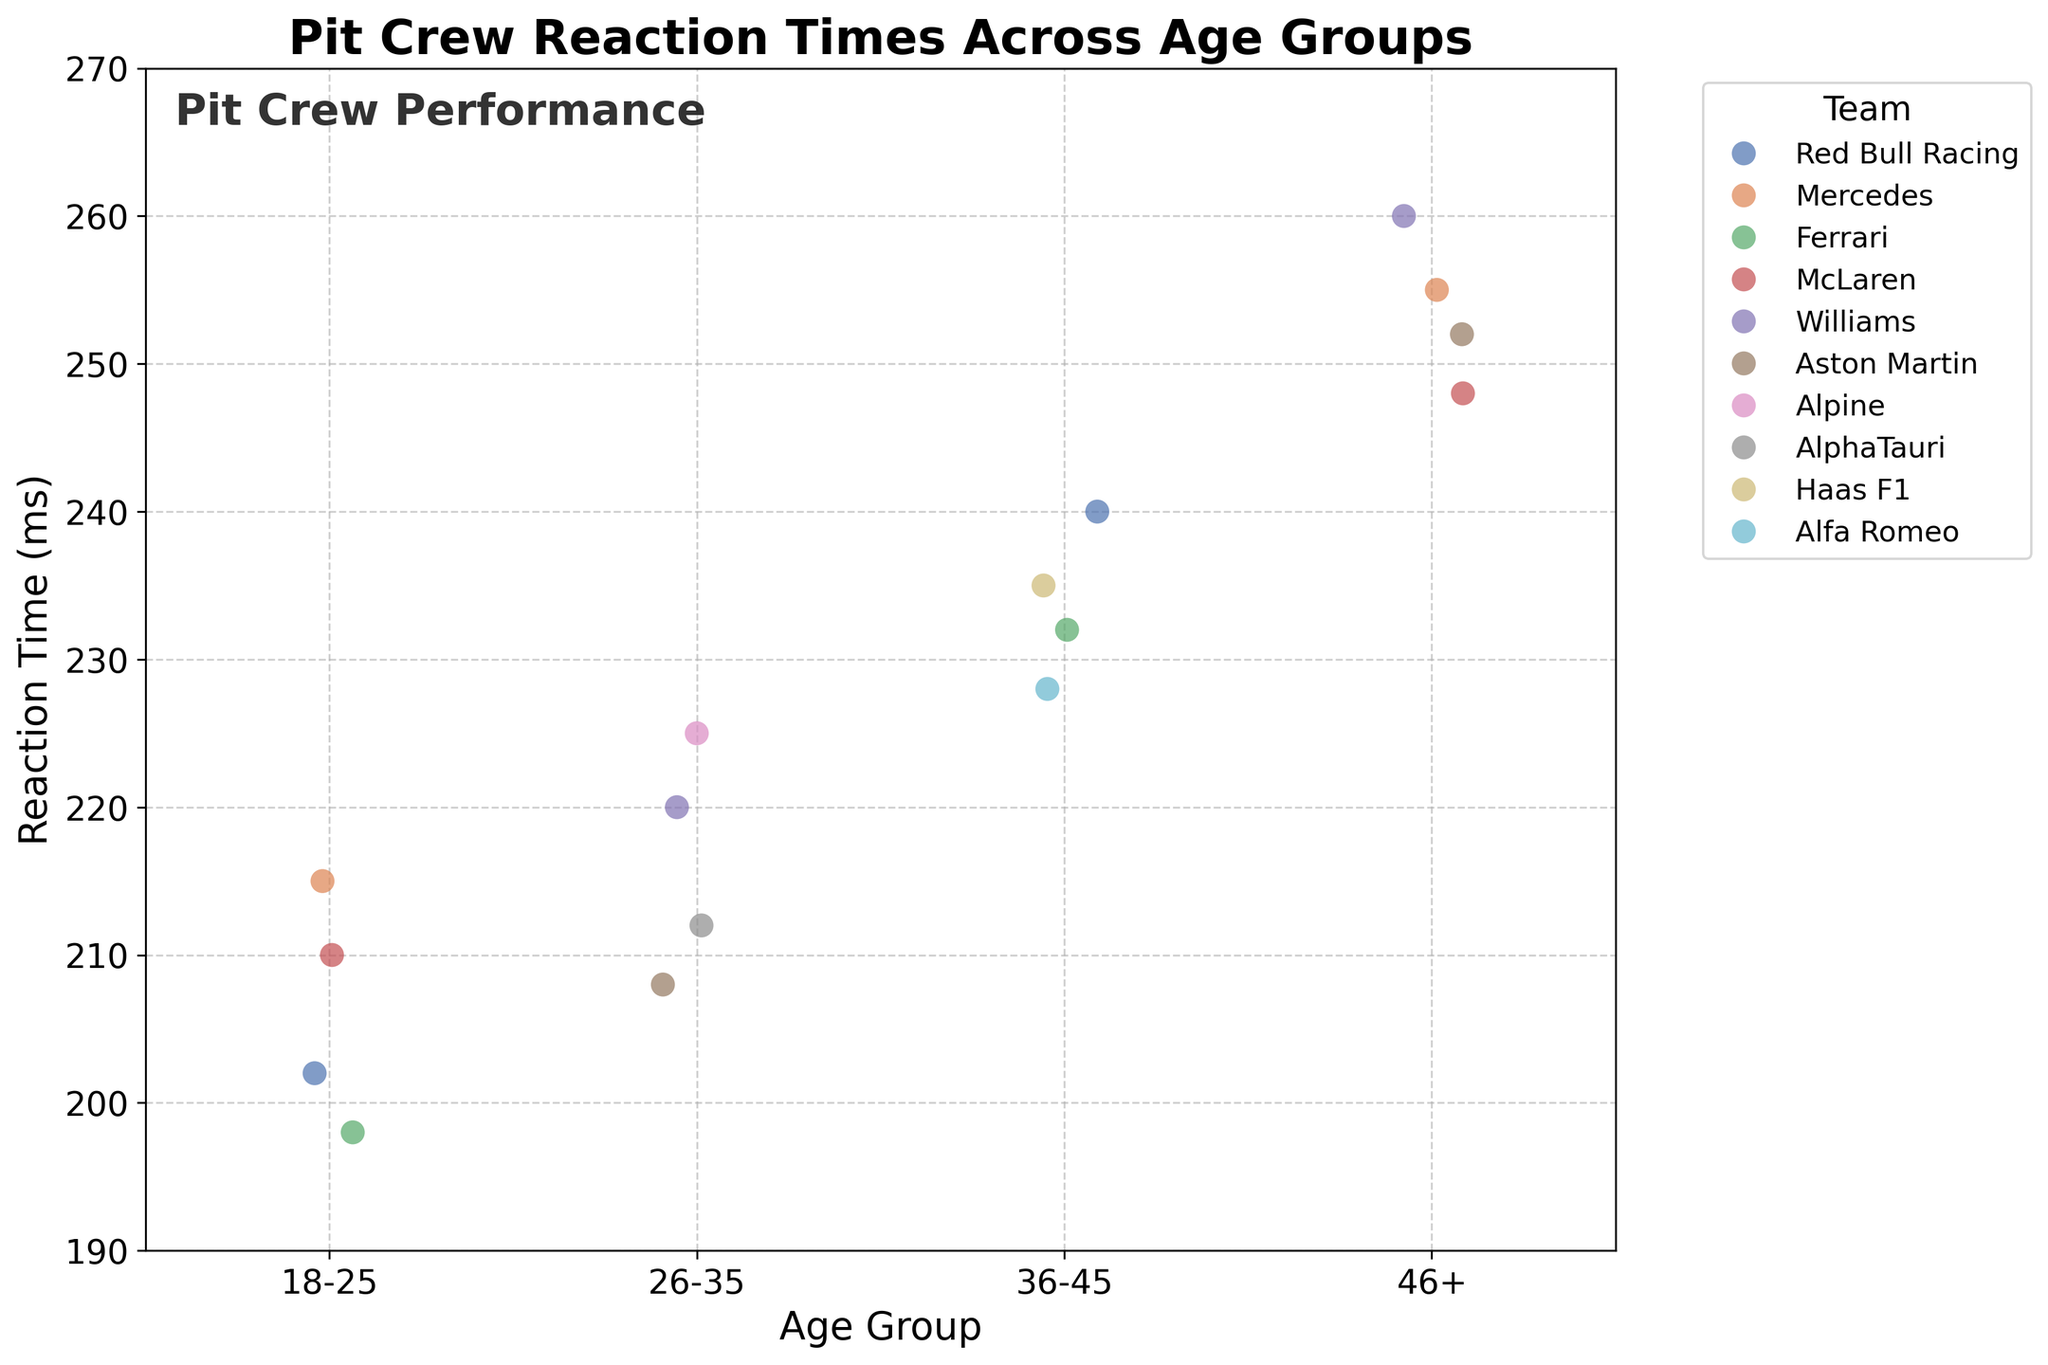What is the title of the figure? The title of the figure is displayed at the top and is a summary of the content of the plot.
Answer: Pit Crew Reaction Times Across Age Groups Which team has the quickest reaction time in the 18-25 age group? Find the smallest reaction time within the 18-25 age group and identify the corresponding team from the plot.
Answer: Ferrari How many teams are represented in the 26-35 age group? Count the number of unique team names within the 26-35 age group.
Answer: 4 What is the average reaction time for the 36-45 age group? Identify all the reaction times for the 36-45 age group from the plot, sum them up, and divide by the number of data points. The reaction times for the 36-45 age group are 235, 228, 240, and 232 ms. The sum is 935 ms and divided by 4 gives us the average.
Answer: 233.75 ms Which age group has the highest overall reaction time? Locate the highest point on the y-axis across all age groups and note the corresponding age group.
Answer: 46+ How does the average reaction time of the 46+ age group compare to the 18-25 age group? Calculate the average reaction times for both age groups, then compare them. For 46+, the average is (255 + 248 + 260 + 252) / 4 = 253.75 ms. For 18-25, the average is (202 + 215 + 198 + 210) / 4 = 206.25 ms. Comparing these, 253.75 ms is greater than 206.25 ms.
Answer: The 46+ age group has higher reaction times Which age group shows the greatest variability in reaction times? Assess the spread or dispersion of data points for each age group. The greater the spread, the higher the variability.
Answer: 46+ How does the reaction time of the McLaren team change from the 18-25 age group to the 46+ age group? Identify the reaction times for McLaren in both age groups and compute the change. In 18-25, McLaren has 210 ms, and in 46+, it has 248 ms. The change is 248 ms - 210 ms.
Answer: Increases by 38 ms Which team has the most consistent reaction times across all age groups? Look for the team whose reaction times vary the least across different age groups. Red Bull Racing’s reaction times are 202 ms (18-25), 240 ms (36-45), which suggests relatively consistent performance.
Answer: Red Bull Racing 